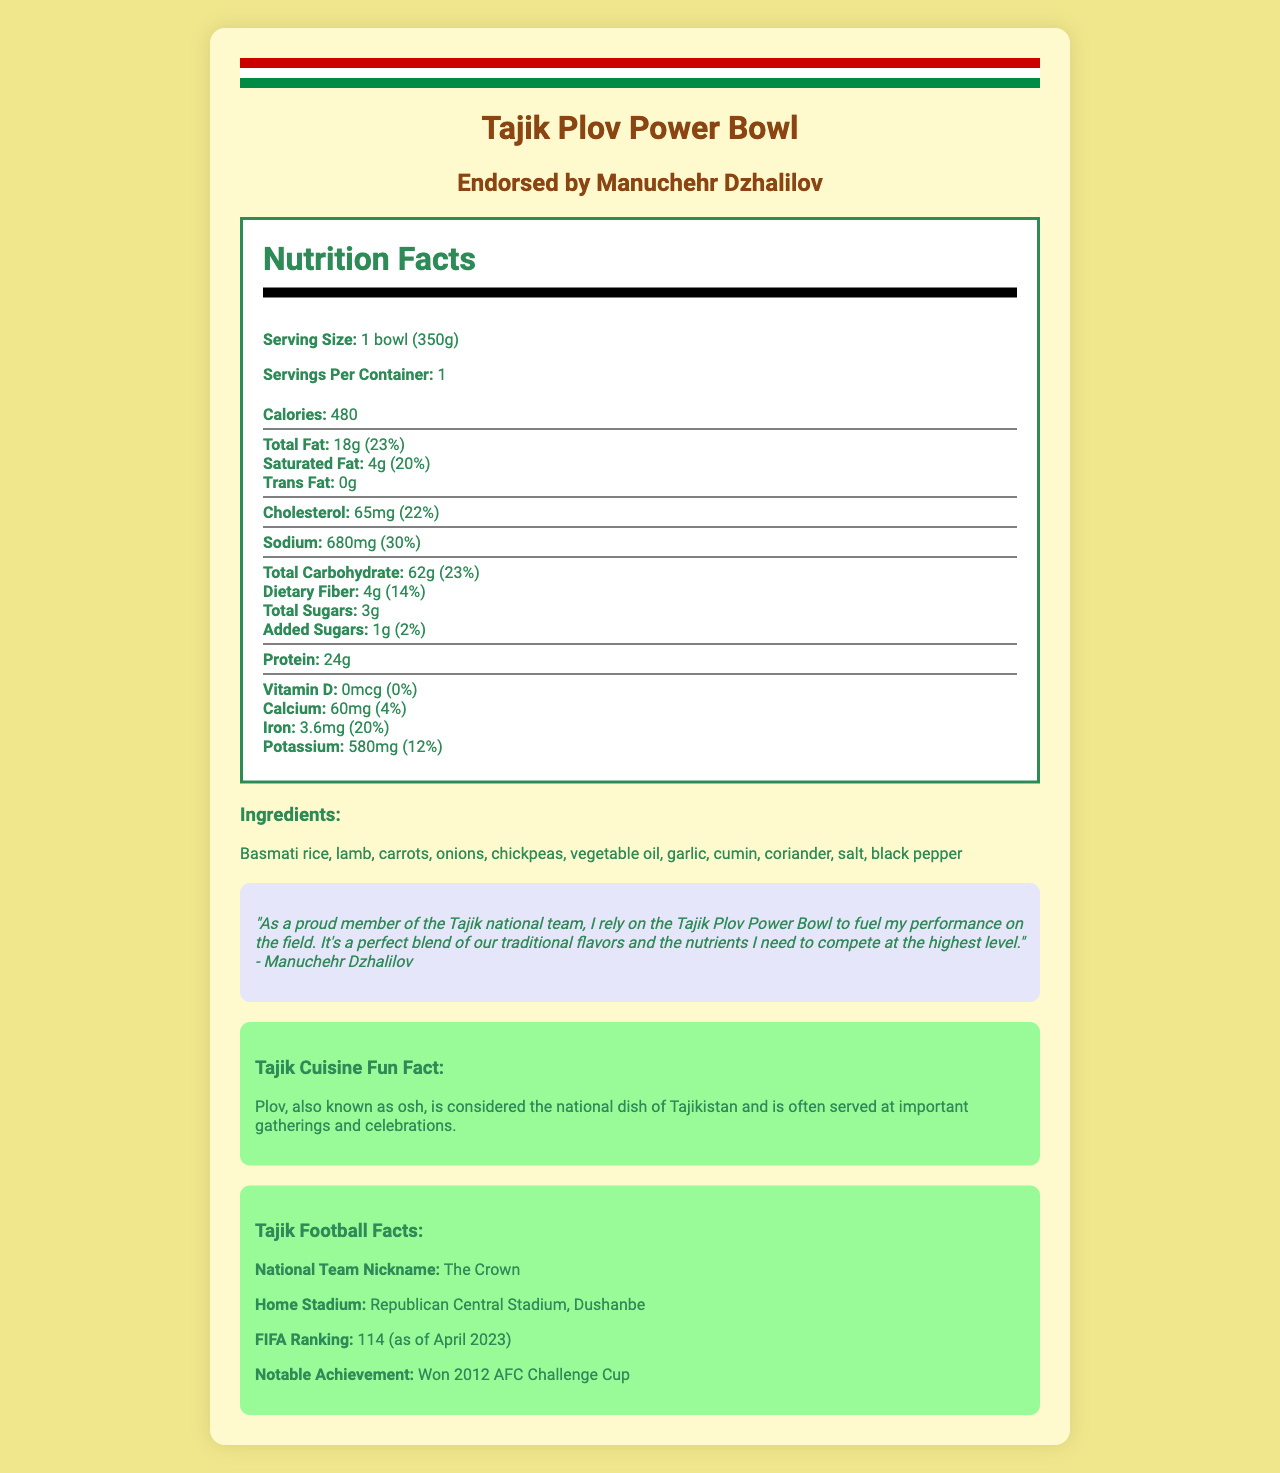what is the serving size of the Tajik Plov Power Bowl? The serving size is mentioned under the "Nutrition Facts" section as "1 bowl (350g)".
Answer: 1 bowl (350g) who endorses the Tajik Plov Power Bowl? The endorsement is noted at the top of the document, stating "Endorsed by Manuchehr Dzhalilov".
Answer: Manuchehr Dzhalilov how much protein does one serving of the Tajik Plov Power Bowl contain? The protein content is listed in the nutrition facts section as "Protein: 24g".
Answer: 24g what is the daily value percentage of sodium in one bowl? The daily value percentage for sodium is given as "30%" in the nutrition facts section.
Answer: 30% what is the notable achievement of the Tajik national team mentioned in the document? This specific football fact is detailed in the "Tajik Football Facts" section.
Answer: Won 2012 AFC Challenge Cup how much total carbohydrate is there in one serving? The total carbohydrate content is shown in the nutrition facts section as "Total Carbohydrate: 62g".
Answer: 62g what is the FIFA ranking of the Tajik national team as of April 2023? The FIFA ranking is mentioned under the "Tajik Football Facts" section as "FIFA Ranking: 114 (as of April 2023)".
Answer: 114 which vitamin has a daily value percentage of 0 in the Tajik Plov Power Bowl? The daily value percentage for Vitamin D is listed as "0%" in the nutrition facts section.
Answer: Vitamin D which ingredient is NOT included in the Tajik Plov Power Bowl? A. Basmati rice B. Potatoes C. Chickpeas D. Garlic The ingredient list includes Basmati rice, Chickpeas, and Garlic, but not Potatoes.
Answer: B. Potatoes what is the nickname for the Tajik national team? A. The Warriors B. The Knights C. The Crown D. The Lions The nickname is mentioned in the document as "The Crown" under the "Tajik Football Facts" section.
Answer: C. The Crown does the Tajik Plov Power Bowl contain any allergens? The allergens section states "None".
Answer: No summarize the main idea of the document. The document covers various aspects of the Tajik Plov Power Bowl, including its nutritional information, ingredients, and endorsement by a national football player. It also offers insights into Tajik football and cultural elements associated with the meal.
Answer: The document provides detailed nutrition facts, ingredients, and endorsement for the Tajik Plov Power Bowl, a packaged meal linked to Tajik culture and football. It highlights the food's nutritional benefits, endorsement by Tajik football player Manuchehr Dzhalilov, and additional facts about Tajik football and cuisine. what is the purpose of the player endorsement quote? The endorsement quote by Manuchehr Dzhalilov serves to connect the product with his performance and nutrition, adding credibility and appeal.
Answer: To associate the product with a notable player and emphasize its benefits for athletes what is the total daily value percentage for added sugars? The daily value percentage for added sugars is listed as "2%" in the nutrition facts section.
Answer: 2% does the document state the price of the Tajik Plov Power Bowl? The document does not include any details about the pricing of the product.
Answer: Not enough information 